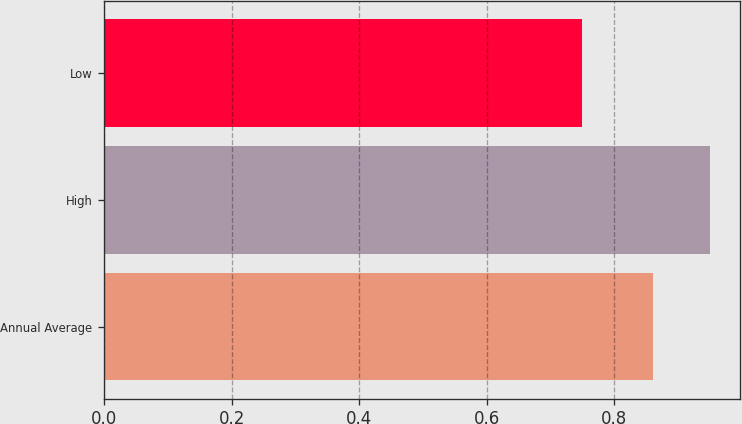<chart> <loc_0><loc_0><loc_500><loc_500><bar_chart><fcel>Annual Average<fcel>High<fcel>Low<nl><fcel>0.86<fcel>0.95<fcel>0.75<nl></chart> 